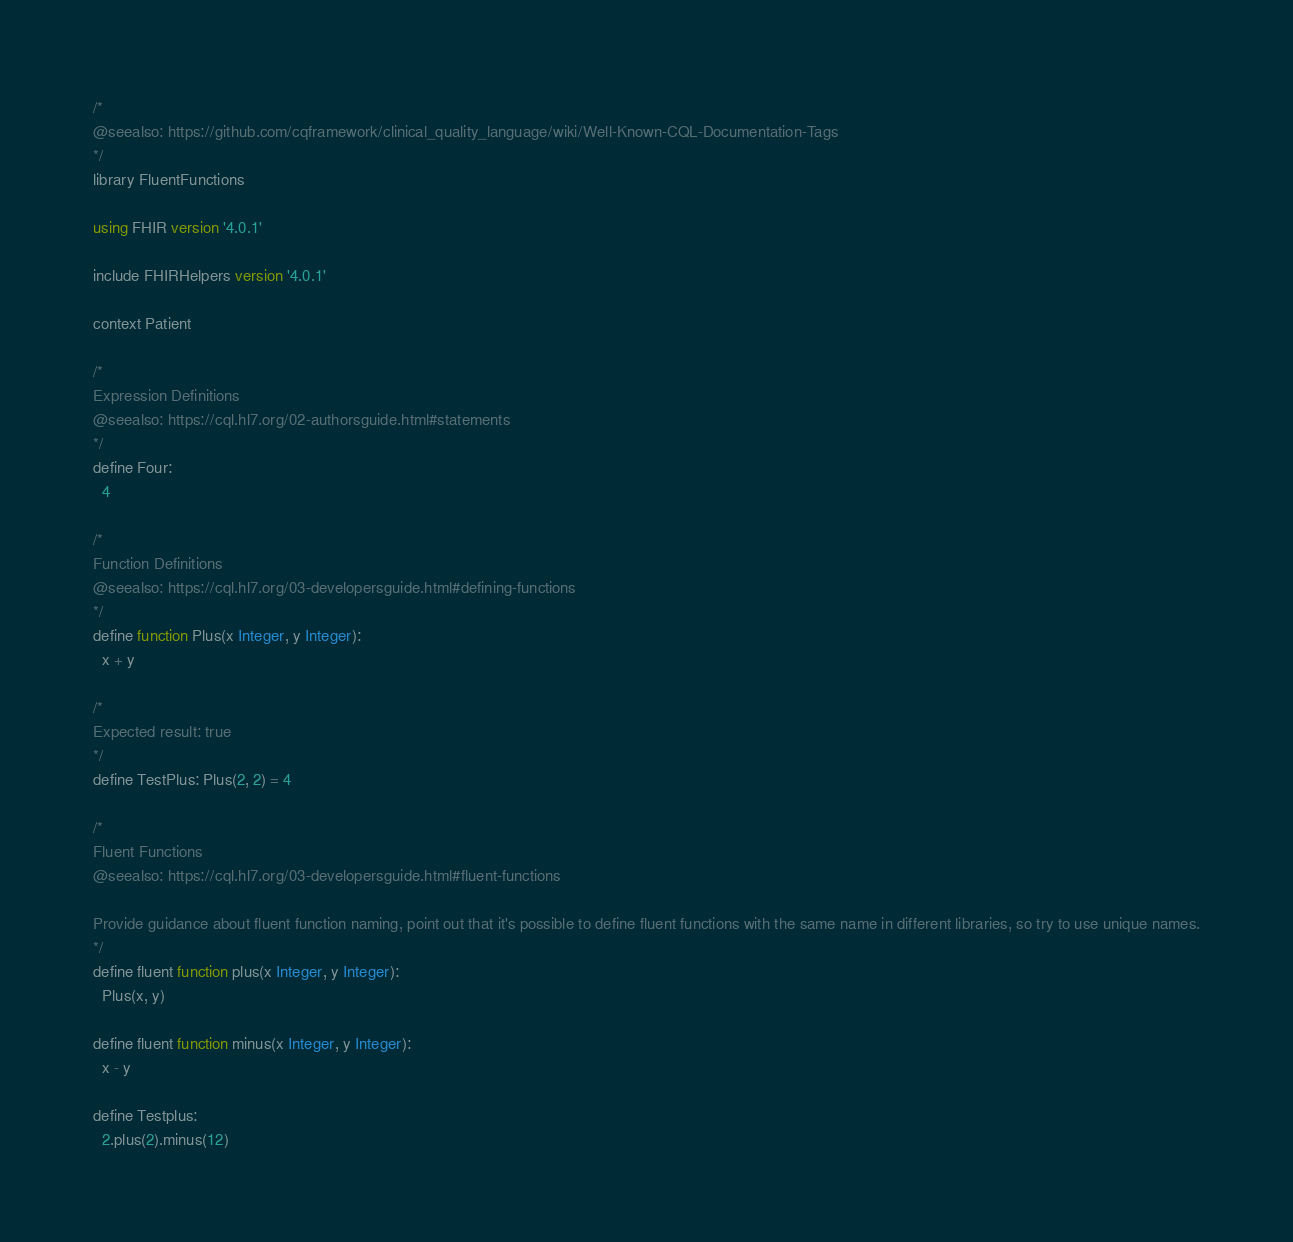Convert code to text. <code><loc_0><loc_0><loc_500><loc_500><_SQL_>/*
@seealso: https://github.com/cqframework/clinical_quality_language/wiki/Well-Known-CQL-Documentation-Tags
*/
library FluentFunctions

using FHIR version '4.0.1'

include FHIRHelpers version '4.0.1'

context Patient

/*
Expression Definitions
@seealso: https://cql.hl7.org/02-authorsguide.html#statements
*/
define Four:
  4

/*
Function Definitions
@seealso: https://cql.hl7.org/03-developersguide.html#defining-functions
*/
define function Plus(x Integer, y Integer):
  x + y

/*
Expected result: true
*/
define TestPlus: Plus(2, 2) = 4

/*
Fluent Functions
@seealso: https://cql.hl7.org/03-developersguide.html#fluent-functions

Provide guidance about fluent function naming, point out that it's possible to define fluent functions with the same name in different libraries, so try to use unique names.
*/
define fluent function plus(x Integer, y Integer):
  Plus(x, y)

define fluent function minus(x Integer, y Integer):
  x - y

define Testplus:
  2.plus(2).minus(12)

</code> 